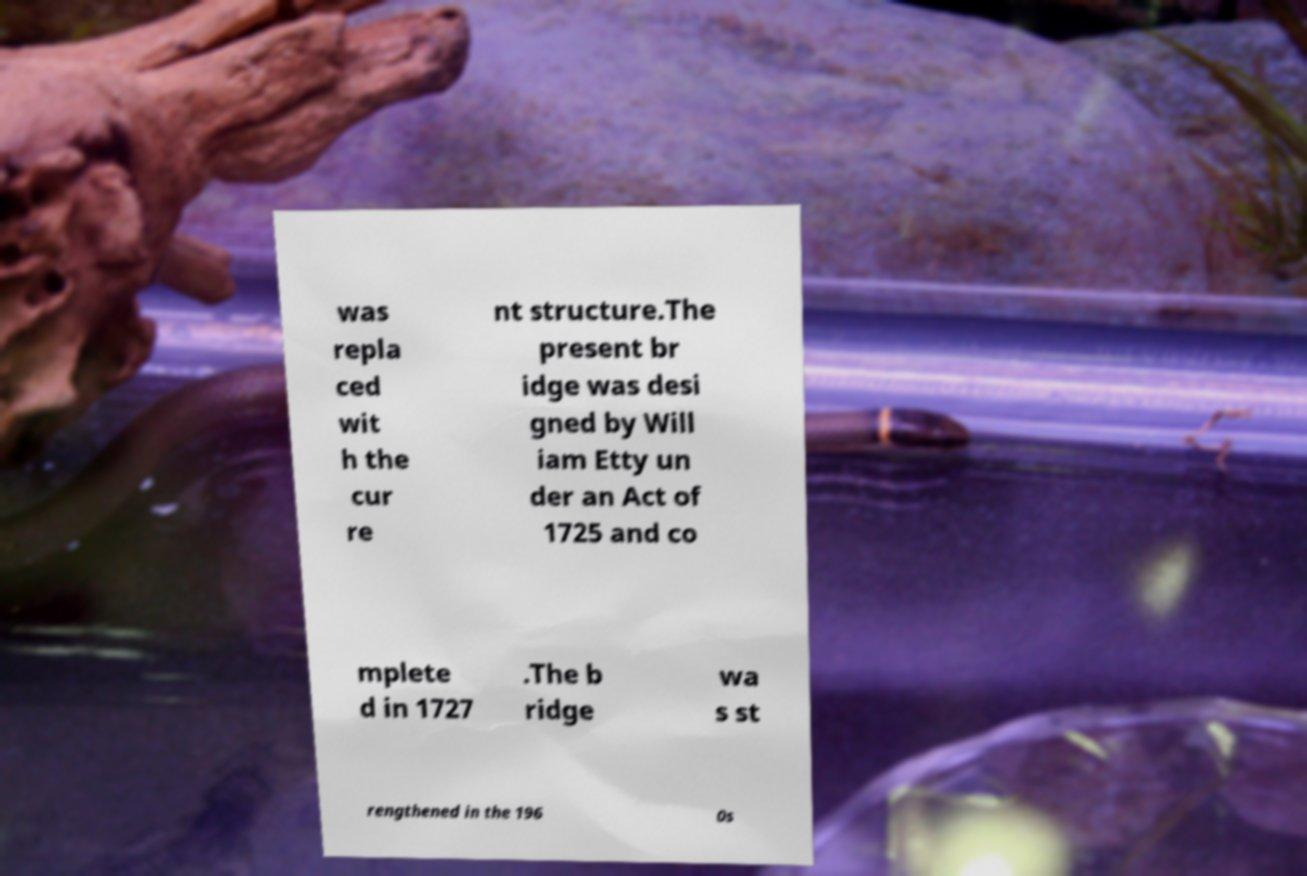Can you accurately transcribe the text from the provided image for me? was repla ced wit h the cur re nt structure.The present br idge was desi gned by Will iam Etty un der an Act of 1725 and co mplete d in 1727 .The b ridge wa s st rengthened in the 196 0s 